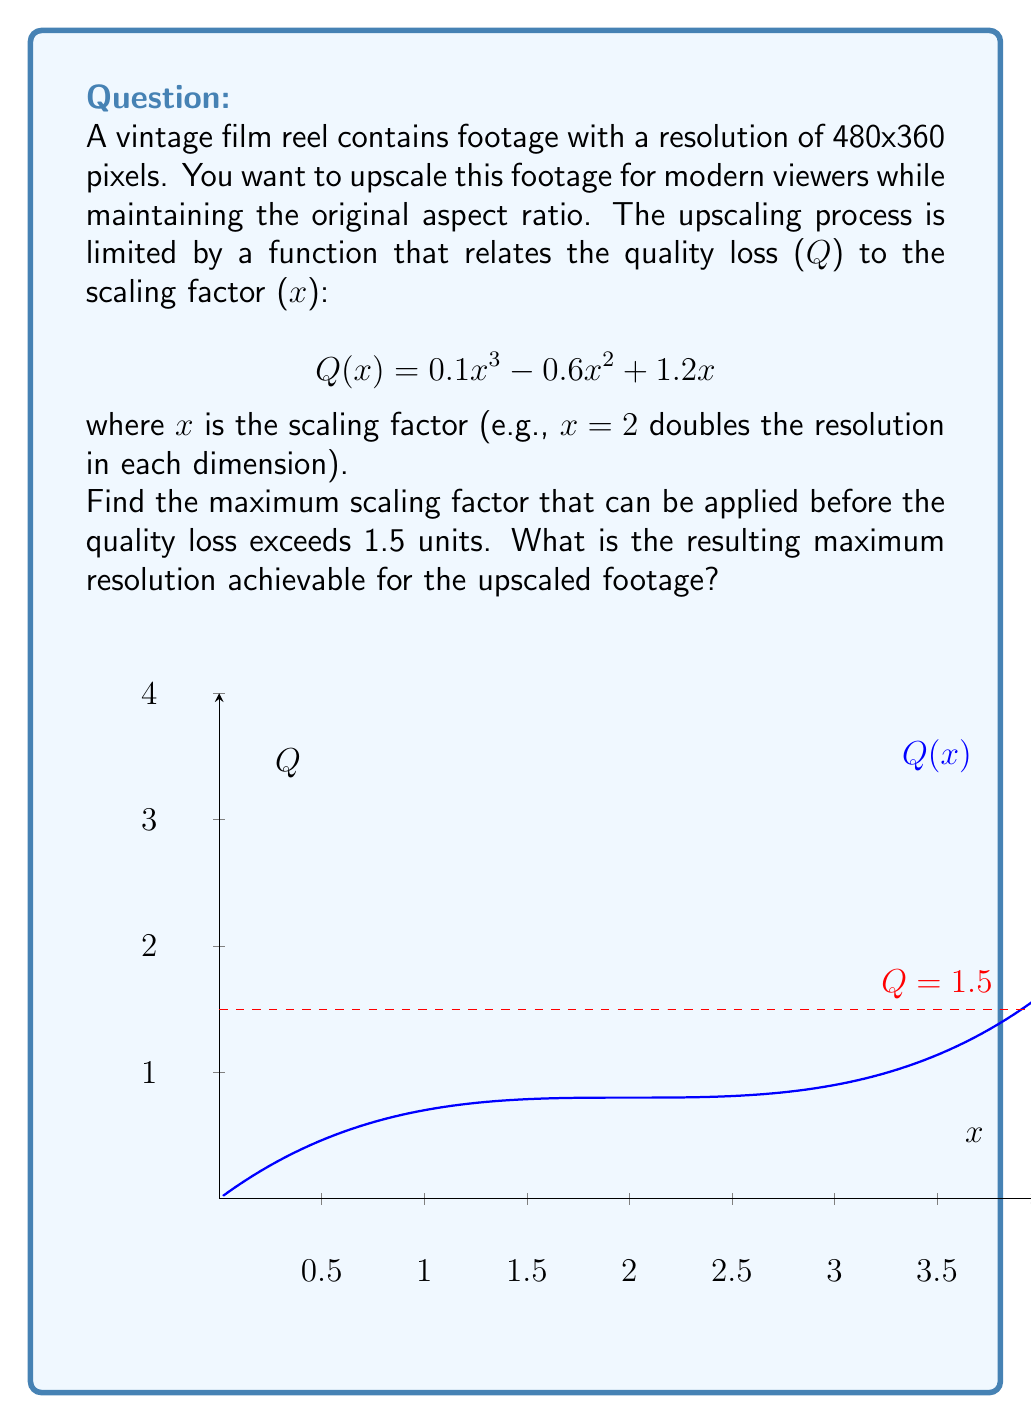Can you answer this question? To solve this problem, we need to follow these steps:

1) First, we need to find the maximum scaling factor x where Q(x) = 1.5. This can be done by solving the equation:

   $$0.1x^3 - 0.6x^2 + 1.2x = 1.5$$

2) Rearranging the equation:

   $$0.1x^3 - 0.6x^2 + 1.2x - 1.5 = 0$$

3) This is a cubic equation. While it can be solved analytically, it's complex. In practice, we would use numerical methods or a graphing calculator. The solution is approximately x ≈ 2.7183.

4) Rounding down to ensure we don't exceed the quality loss limit, we'll use x = 2.7.

5) Now, we can calculate the new resolution:
   - Original width: 480 pixels
   - Original height: 360 pixels
   - New width: 480 * 2.7 = 1296 pixels
   - New height: 360 * 2.7 = 972 pixels

6) Rounding down to the nearest whole pixel (as partial pixels don't exist):
   - Maximum achievable resolution: 1296 x 972 pixels
Answer: 1296 x 972 pixels 